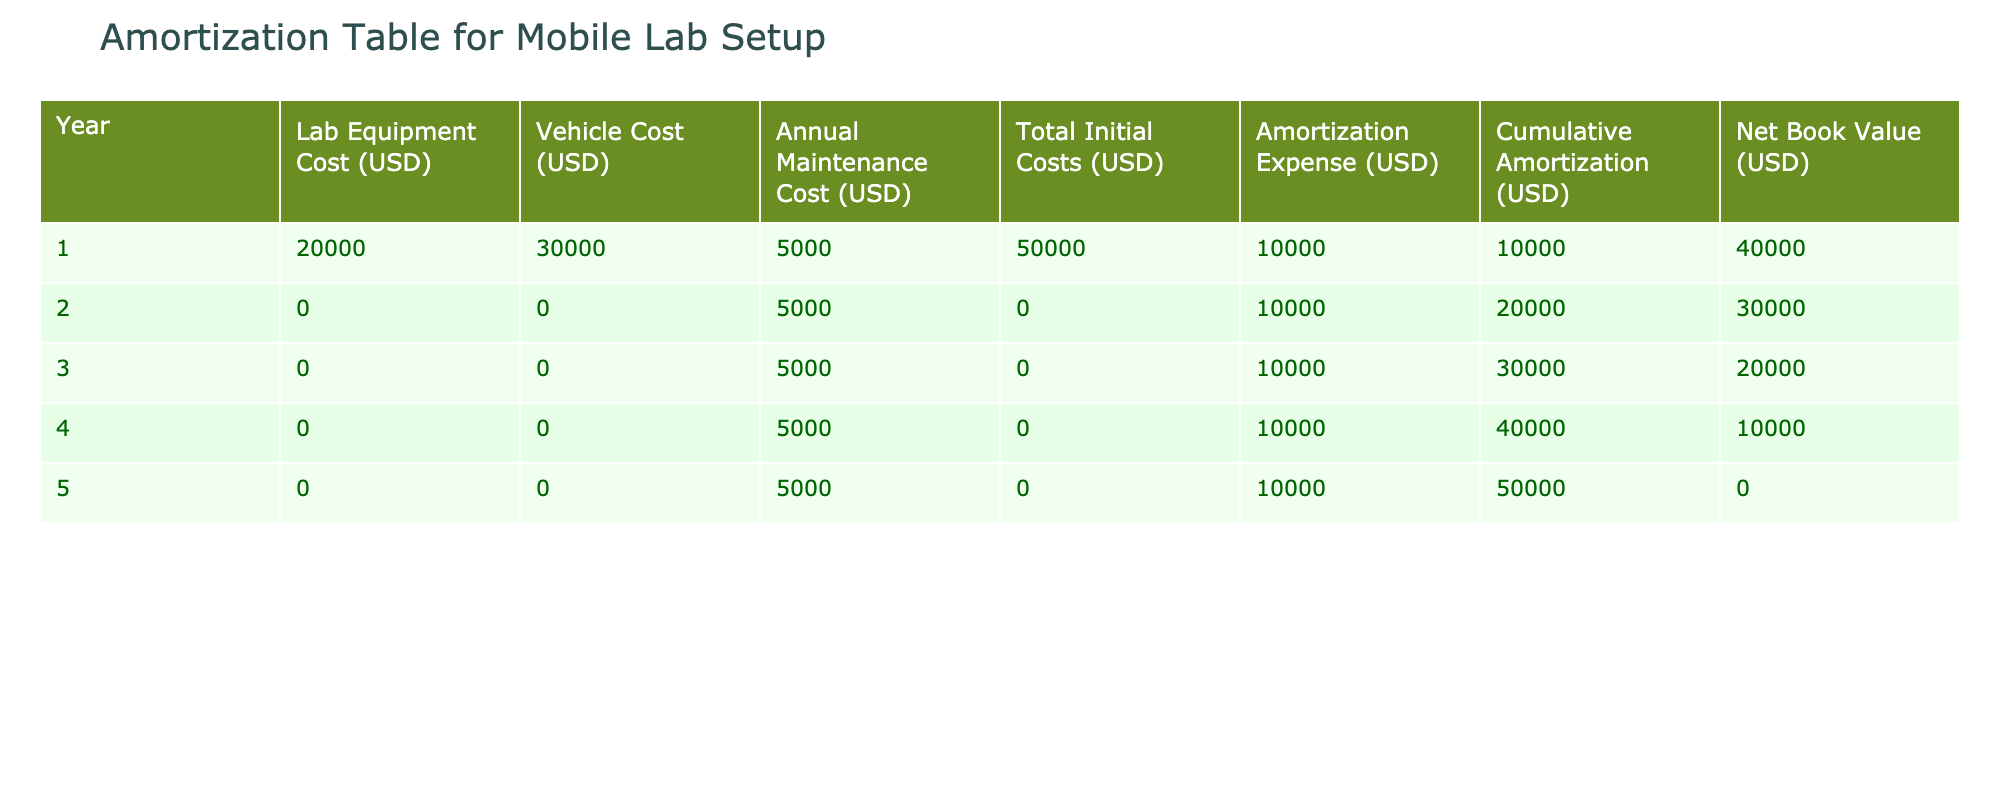What is the total initial cost for the mobile lab setup? The total initial cost is found in the "Total Initial Costs (USD)" column for year 1, which lists the value as 50000 USD.
Answer: 50000 USD In which year is the cumulative amortization equal to 30000 USD? To find this, look at the "Cumulative Amortization (USD)" column. The value reaches 30000 USD in year 3.
Answer: Year 3 What is the net book value at the end of year 4? The net book value at the end of year 4 can be found in the "Net Book Value (USD)" column for that year, which indicates a value of 10000 USD.
Answer: 10000 USD What are the total amortization expenses over the 5 years? The amortization expenses are listed in the "Amortization Expense (USD)" column for each year. By summing them: 10000 + 10000 + 10000 + 10000 + 10000 = 50000 USD.
Answer: 50000 USD Is the annual maintenance cost constant throughout the 5 years? The annual maintenance cost is listed as 5000 USD for each year, indicating it is indeed constant.
Answer: Yes What is the average annual amortization expense over the 5 years? The total amortization expense over the 5 years is 50000 USD. To find the average, divide by the number of years: 50000 / 5 = 10000 USD.
Answer: 10000 USD In which year does the net book value first drop below 20000 USD? Looking at the "Net Book Value (USD)" column, the first year in which the net book value drops below 20000 USD is year 4, which shows a value of 10000 USD.
Answer: Year 4 What is the difference in cumulative amortization between year 2 and year 4? The cumulative amortization in year 2 is 20000 USD and in year 4 is 40000 USD. The difference is 40000 - 20000 = 20000 USD.
Answer: 20000 USD Is the vehicle cost higher than the lab equipment cost in the first year? In the first year, the lab equipment cost is 20000 USD and the vehicle cost is 30000 USD, which confirms that the vehicle cost is indeed higher.
Answer: Yes 